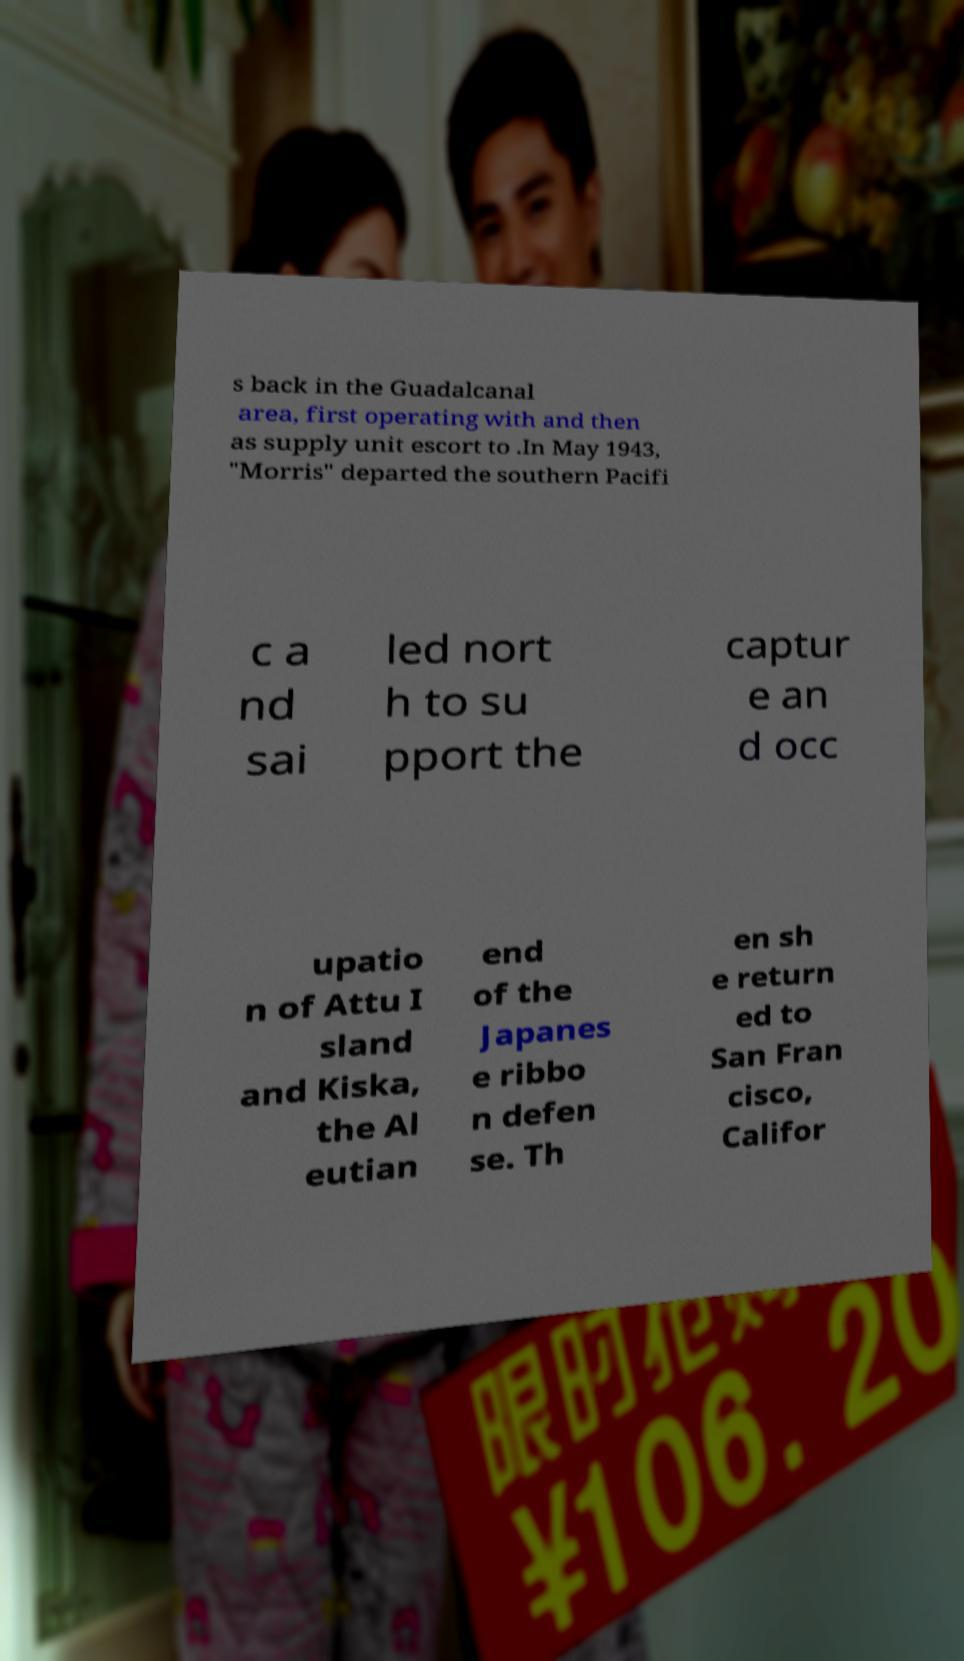Please identify and transcribe the text found in this image. s back in the Guadalcanal area, first operating with and then as supply unit escort to .In May 1943, "Morris" departed the southern Pacifi c a nd sai led nort h to su pport the captur e an d occ upatio n of Attu I sland and Kiska, the Al eutian end of the Japanes e ribbo n defen se. Th en sh e return ed to San Fran cisco, Califor 